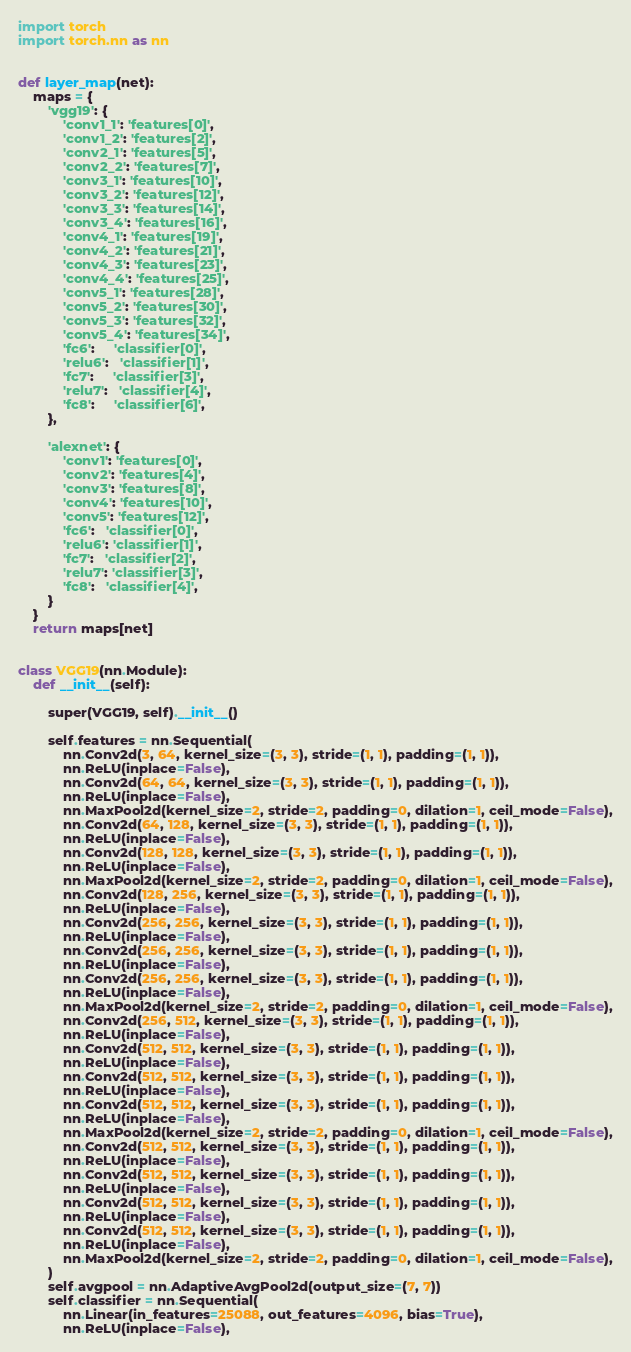<code> <loc_0><loc_0><loc_500><loc_500><_Python_>import torch
import torch.nn as nn


def layer_map(net):
    maps = {
        'vgg19': {
            'conv1_1': 'features[0]',
            'conv1_2': 'features[2]',
            'conv2_1': 'features[5]',
            'conv2_2': 'features[7]',
            'conv3_1': 'features[10]',
            'conv3_2': 'features[12]',
            'conv3_3': 'features[14]',
            'conv3_4': 'features[16]',
            'conv4_1': 'features[19]',
            'conv4_2': 'features[21]',
            'conv4_3': 'features[23]',
            'conv4_4': 'features[25]',
            'conv5_1': 'features[28]',
            'conv5_2': 'features[30]',
            'conv5_3': 'features[32]',
            'conv5_4': 'features[34]',
            'fc6':     'classifier[0]',
            'relu6':   'classifier[1]',
            'fc7':     'classifier[3]',
            'relu7':   'classifier[4]',
            'fc8':     'classifier[6]',
        },

        'alexnet': {
            'conv1': 'features[0]',
            'conv2': 'features[4]',
            'conv3': 'features[8]',
            'conv4': 'features[10]',
            'conv5': 'features[12]',
            'fc6':   'classifier[0]',
            'relu6': 'classifier[1]',
            'fc7':   'classifier[2]',
            'relu7': 'classifier[3]',
            'fc8':   'classifier[4]',
        }
    }
    return maps[net]


class VGG19(nn.Module):
    def __init__(self):

        super(VGG19, self).__init__()

        self.features = nn.Sequential(
            nn.Conv2d(3, 64, kernel_size=(3, 3), stride=(1, 1), padding=(1, 1)),
            nn.ReLU(inplace=False),
            nn.Conv2d(64, 64, kernel_size=(3, 3), stride=(1, 1), padding=(1, 1)),
            nn.ReLU(inplace=False),
            nn.MaxPool2d(kernel_size=2, stride=2, padding=0, dilation=1, ceil_mode=False),
            nn.Conv2d(64, 128, kernel_size=(3, 3), stride=(1, 1), padding=(1, 1)),
            nn.ReLU(inplace=False),
            nn.Conv2d(128, 128, kernel_size=(3, 3), stride=(1, 1), padding=(1, 1)),
            nn.ReLU(inplace=False),
            nn.MaxPool2d(kernel_size=2, stride=2, padding=0, dilation=1, ceil_mode=False),
            nn.Conv2d(128, 256, kernel_size=(3, 3), stride=(1, 1), padding=(1, 1)),
            nn.ReLU(inplace=False),
            nn.Conv2d(256, 256, kernel_size=(3, 3), stride=(1, 1), padding=(1, 1)),
            nn.ReLU(inplace=False),
            nn.Conv2d(256, 256, kernel_size=(3, 3), stride=(1, 1), padding=(1, 1)),
            nn.ReLU(inplace=False),
            nn.Conv2d(256, 256, kernel_size=(3, 3), stride=(1, 1), padding=(1, 1)),
            nn.ReLU(inplace=False),
            nn.MaxPool2d(kernel_size=2, stride=2, padding=0, dilation=1, ceil_mode=False),
            nn.Conv2d(256, 512, kernel_size=(3, 3), stride=(1, 1), padding=(1, 1)),
            nn.ReLU(inplace=False),
            nn.Conv2d(512, 512, kernel_size=(3, 3), stride=(1, 1), padding=(1, 1)),
            nn.ReLU(inplace=False),
            nn.Conv2d(512, 512, kernel_size=(3, 3), stride=(1, 1), padding=(1, 1)),
            nn.ReLU(inplace=False),
            nn.Conv2d(512, 512, kernel_size=(3, 3), stride=(1, 1), padding=(1, 1)),
            nn.ReLU(inplace=False),
            nn.MaxPool2d(kernel_size=2, stride=2, padding=0, dilation=1, ceil_mode=False),
            nn.Conv2d(512, 512, kernel_size=(3, 3), stride=(1, 1), padding=(1, 1)),
            nn.ReLU(inplace=False),
            nn.Conv2d(512, 512, kernel_size=(3, 3), stride=(1, 1), padding=(1, 1)),
            nn.ReLU(inplace=False),
            nn.Conv2d(512, 512, kernel_size=(3, 3), stride=(1, 1), padding=(1, 1)),
            nn.ReLU(inplace=False),
            nn.Conv2d(512, 512, kernel_size=(3, 3), stride=(1, 1), padding=(1, 1)),
            nn.ReLU(inplace=False),
            nn.MaxPool2d(kernel_size=2, stride=2, padding=0, dilation=1, ceil_mode=False),
        )
        self.avgpool = nn.AdaptiveAvgPool2d(output_size=(7, 7))
        self.classifier = nn.Sequential(
            nn.Linear(in_features=25088, out_features=4096, bias=True),
            nn.ReLU(inplace=False),</code> 